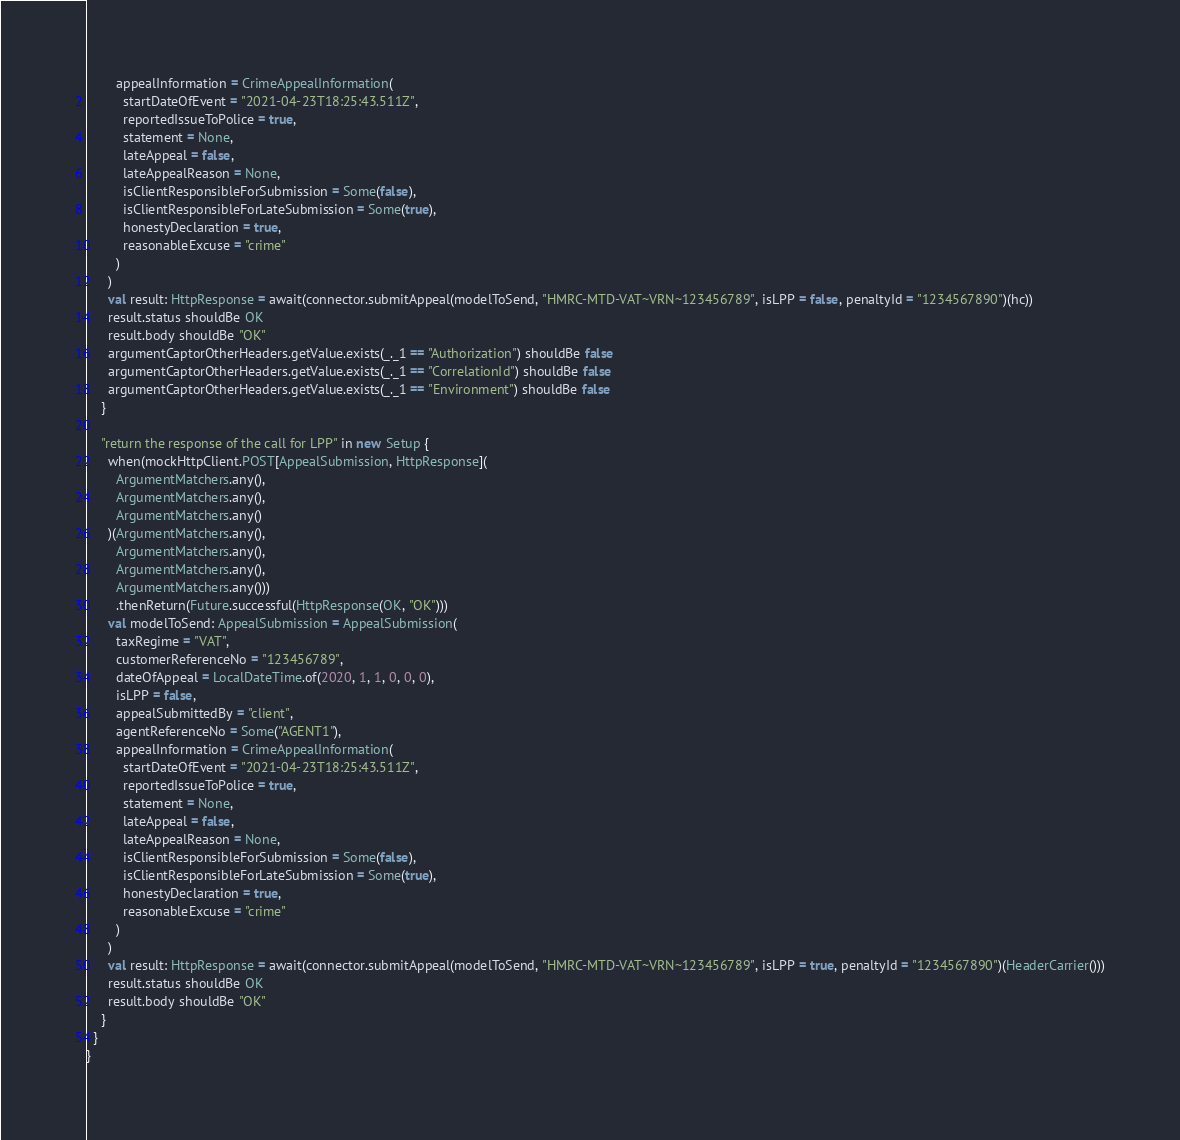<code> <loc_0><loc_0><loc_500><loc_500><_Scala_>        appealInformation = CrimeAppealInformation(
          startDateOfEvent = "2021-04-23T18:25:43.511Z",
          reportedIssueToPolice = true,
          statement = None,
          lateAppeal = false,
          lateAppealReason = None,
          isClientResponsibleForSubmission = Some(false),
          isClientResponsibleForLateSubmission = Some(true),
          honestyDeclaration = true,
          reasonableExcuse = "crime"
        )
      )
      val result: HttpResponse = await(connector.submitAppeal(modelToSend, "HMRC-MTD-VAT~VRN~123456789", isLPP = false, penaltyId = "1234567890")(hc))
      result.status shouldBe OK
      result.body shouldBe "OK"
      argumentCaptorOtherHeaders.getValue.exists(_._1 == "Authorization") shouldBe false
      argumentCaptorOtherHeaders.getValue.exists(_._1 == "CorrelationId") shouldBe false
      argumentCaptorOtherHeaders.getValue.exists(_._1 == "Environment") shouldBe false
    }

    "return the response of the call for LPP" in new Setup {
      when(mockHttpClient.POST[AppealSubmission, HttpResponse](
        ArgumentMatchers.any(),
        ArgumentMatchers.any(),
        ArgumentMatchers.any()
      )(ArgumentMatchers.any(),
        ArgumentMatchers.any(),
        ArgumentMatchers.any(),
        ArgumentMatchers.any()))
        .thenReturn(Future.successful(HttpResponse(OK, "OK")))
      val modelToSend: AppealSubmission = AppealSubmission(
        taxRegime = "VAT",
        customerReferenceNo = "123456789",
        dateOfAppeal = LocalDateTime.of(2020, 1, 1, 0, 0, 0),
        isLPP = false,
        appealSubmittedBy = "client",
        agentReferenceNo = Some("AGENT1"),
        appealInformation = CrimeAppealInformation(
          startDateOfEvent = "2021-04-23T18:25:43.511Z",
          reportedIssueToPolice = true,
          statement = None,
          lateAppeal = false,
          lateAppealReason = None,
          isClientResponsibleForSubmission = Some(false),
          isClientResponsibleForLateSubmission = Some(true),
          honestyDeclaration = true,
          reasonableExcuse = "crime"
        )
      )
      val result: HttpResponse = await(connector.submitAppeal(modelToSend, "HMRC-MTD-VAT~VRN~123456789", isLPP = true, penaltyId = "1234567890")(HeaderCarrier()))
      result.status shouldBe OK
      result.body shouldBe "OK"
    }
  }
}
</code> 